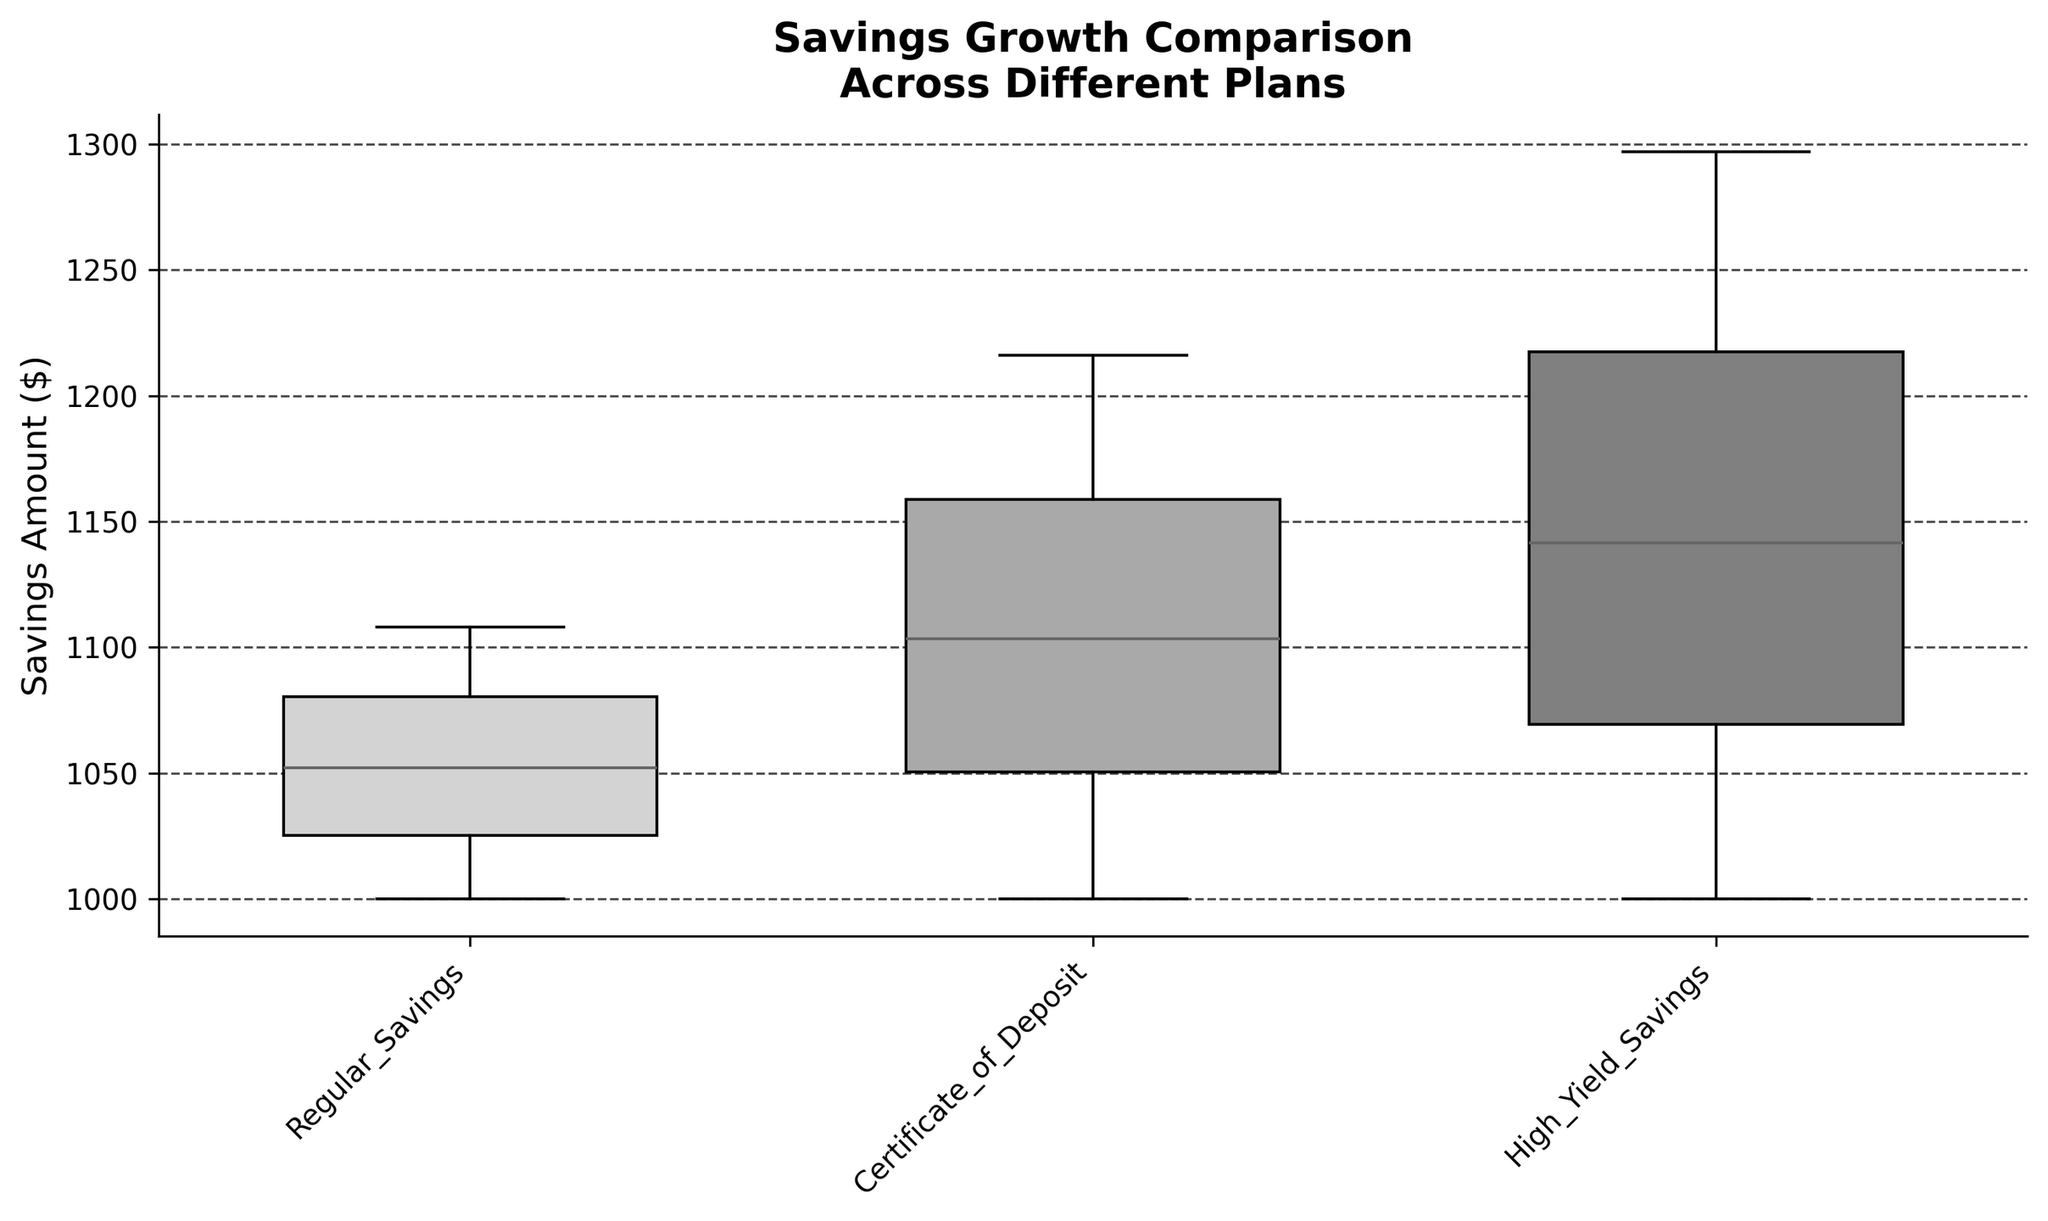What is the title of the plot? The title can be found at the top of the figure. It gives an overview of what the plot is about.
Answer: Savings Growth Comparison Across Different Plans What does the y-axis represent? The label on the y-axis indicates what is being measured in the plot.
Answer: Savings Amount ($) Which savings plan shows the highest savings amount at the end of the period? By comparing the upper whiskers of the box plots, you can identify the maximum values for each plan. The highest savings amount will be the one with the highest upper whisker.
Answer: High-Yield Savings Account What colors are used for the boxes representing the different savings plans? The colors of the boxes can be identified visually from the figure.
Answer: Light gray, dark gray, and medium gray What is the median savings amount for the Certificate of Deposit plan? The median is the line inside each box plot. For the Certificate of Deposit plan, locate the line within its box to read the median value.
Answer: Approximately $1100 Which savings plan appears to have the greatest range in savings amounts? The range is the difference between the maximum and minimum values shown by the whiskers of the box plots. The plan with the largest distance between the top and bottom whiskers has the greatest range.
Answer: High-Yield Savings Account What is the interquartile range (IQR) for the Regular Savings plan? The IQR is the range between the first quartile (bottom of the box) and the third quartile (top of the box). Measure this range on the y-axis for the Regular Savings plan.
Answer: Approximately $21 How do the savings amounts for the High-Yield Savings plan compare to the Regular Savings plan? Compare the medians, the ranges, and the whiskers of the two box plots to examine the spread and central tendencies of their savings amounts.
Answer: The High-Yield Savings plan has higher savings amounts overall Which savings plan has the smallest variability in savings amounts? Variability can be observed by the size of the boxes and the length of the whiskers. The plan with the smallest box and shortest whiskers has the least variability.
Answer: Regular Savings Account Is the median savings amount for the High-Yield Savings Account greater than the third quartile of the Regular Savings Account? Compare the median line of the High-Yield Savings Account plot with the top line of the box (third quartile) of the Regular Savings Account plot.
Answer: Yes 